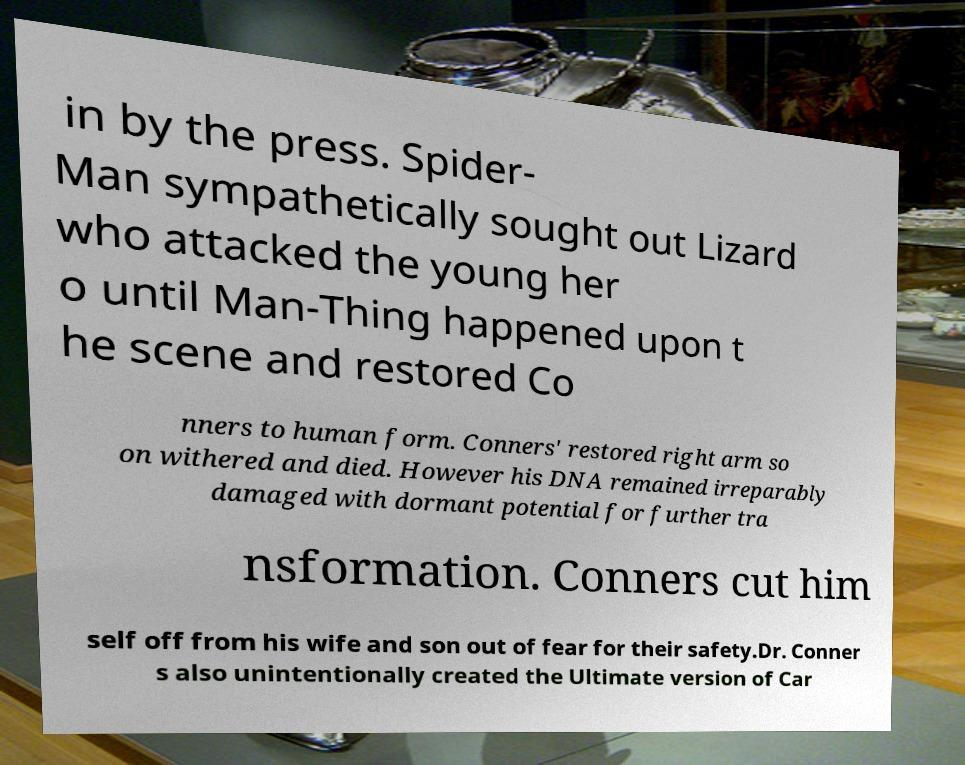What messages or text are displayed in this image? I need them in a readable, typed format. in by the press. Spider- Man sympathetically sought out Lizard who attacked the young her o until Man-Thing happened upon t he scene and restored Co nners to human form. Conners' restored right arm so on withered and died. However his DNA remained irreparably damaged with dormant potential for further tra nsformation. Conners cut him self off from his wife and son out of fear for their safety.Dr. Conner s also unintentionally created the Ultimate version of Car 